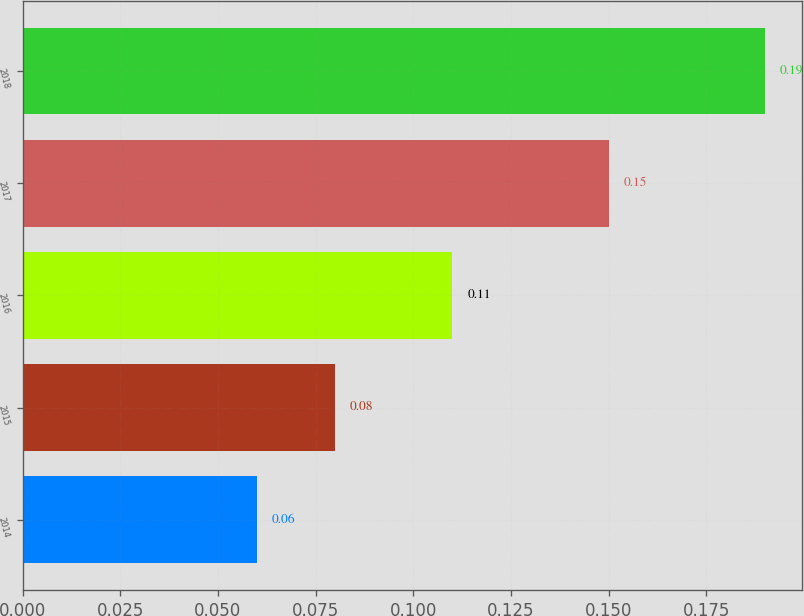Convert chart to OTSL. <chart><loc_0><loc_0><loc_500><loc_500><bar_chart><fcel>2014<fcel>2015<fcel>2016<fcel>2017<fcel>2018<nl><fcel>0.06<fcel>0.08<fcel>0.11<fcel>0.15<fcel>0.19<nl></chart> 